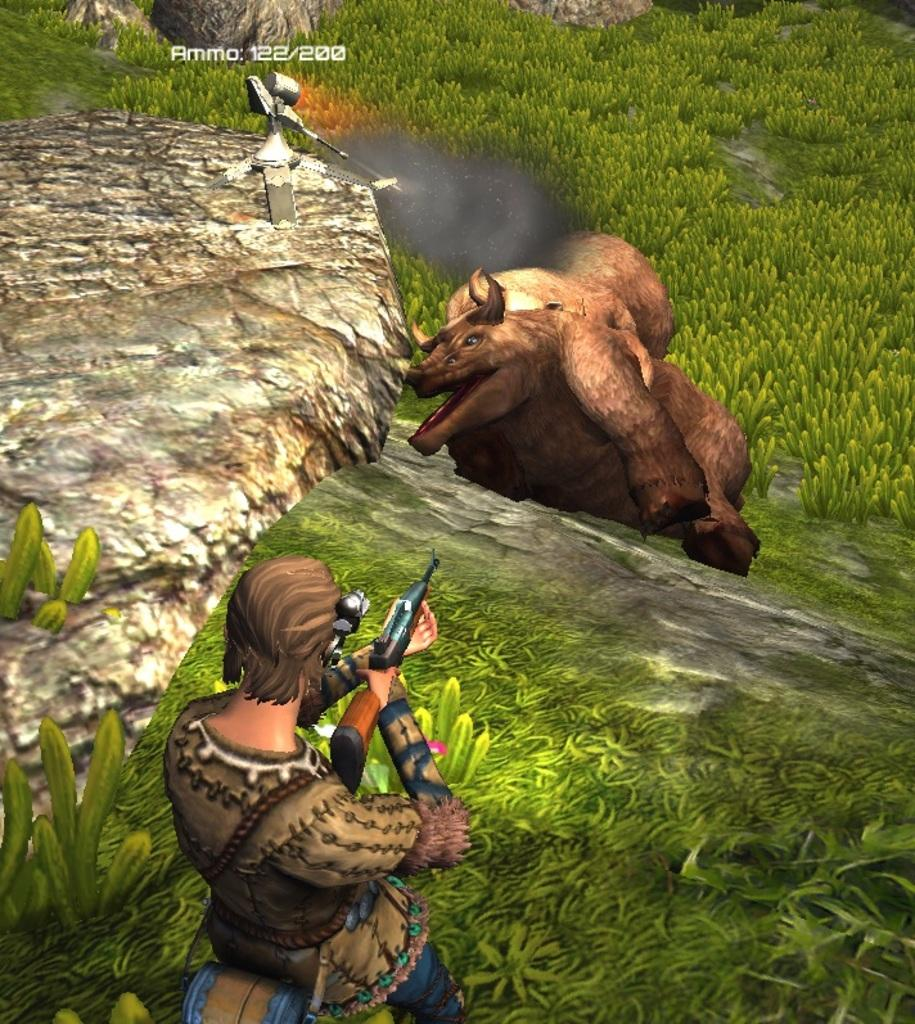What type of picture is shown in the image? There is an animation picture in the image. What is the person in the animation doing? The person is holding a gun and shooting at an animal in the animation. What other elements can be seen in the image? There are rocks and plants in the image. How much debt does the person in the animation have? There is no information about the person's debt in the image, as it is an animation and not a real-life scenario. Can you tell me how many eggs are visible in the image? There are no eggs visible in the image; it features an animation with a person holding a gun and shooting at an animal, along with rocks and plants. 